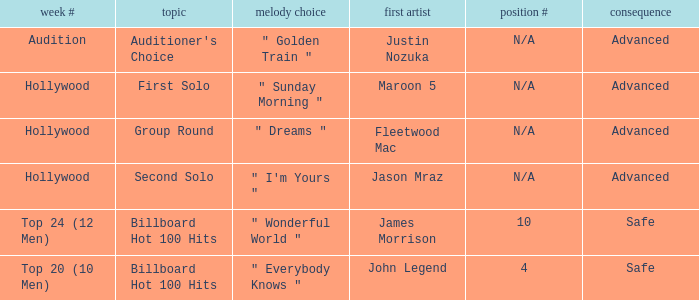During which weeks is the subject matter focused on the auditioner's preference? Audition. 